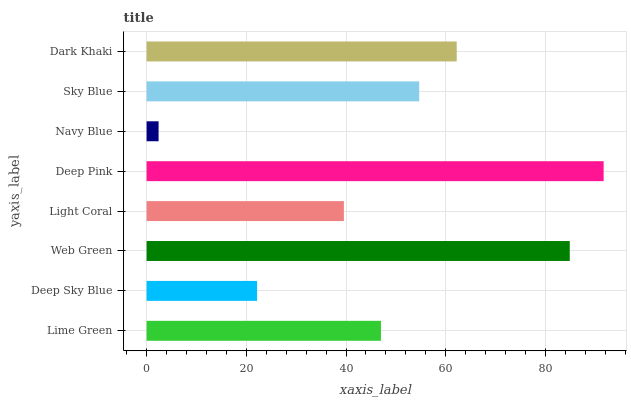Is Navy Blue the minimum?
Answer yes or no. Yes. Is Deep Pink the maximum?
Answer yes or no. Yes. Is Deep Sky Blue the minimum?
Answer yes or no. No. Is Deep Sky Blue the maximum?
Answer yes or no. No. Is Lime Green greater than Deep Sky Blue?
Answer yes or no. Yes. Is Deep Sky Blue less than Lime Green?
Answer yes or no. Yes. Is Deep Sky Blue greater than Lime Green?
Answer yes or no. No. Is Lime Green less than Deep Sky Blue?
Answer yes or no. No. Is Sky Blue the high median?
Answer yes or no. Yes. Is Lime Green the low median?
Answer yes or no. Yes. Is Deep Pink the high median?
Answer yes or no. No. Is Sky Blue the low median?
Answer yes or no. No. 